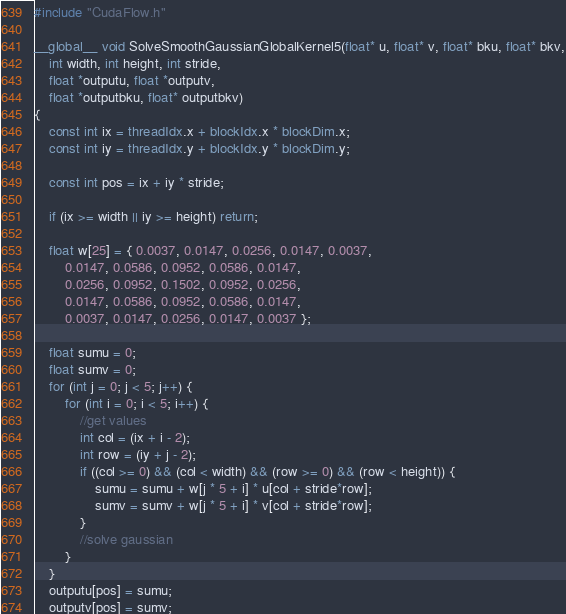<code> <loc_0><loc_0><loc_500><loc_500><_Cuda_>#include "CudaFlow.h"

__global__ void SolveSmoothGaussianGlobalKernel5(float* u, float* v, float* bku, float* bkv,
	int width, int height, int stride,
	float *outputu, float *outputv,
	float *outputbku, float* outputbkv)
{
	const int ix = threadIdx.x + blockIdx.x * blockDim.x;
	const int iy = threadIdx.y + blockIdx.y * blockDim.y;

	const int pos = ix + iy * stride;

	if (ix >= width || iy >= height) return;

	float w[25] = { 0.0037, 0.0147, 0.0256, 0.0147, 0.0037,
		0.0147, 0.0586, 0.0952, 0.0586, 0.0147,
		0.0256, 0.0952, 0.1502, 0.0952, 0.0256,
		0.0147, 0.0586, 0.0952, 0.0586, 0.0147,
		0.0037, 0.0147, 0.0256, 0.0147, 0.0037 };

	float sumu = 0;
	float sumv = 0;
	for (int j = 0; j < 5; j++) {
		for (int i = 0; i < 5; i++) {
			//get values
			int col = (ix + i - 2);
			int row = (iy + j - 2);
			if ((col >= 0) && (col < width) && (row >= 0) && (row < height)) {
				sumu = sumu + w[j * 5 + i] * u[col + stride*row];
				sumv = sumv + w[j * 5 + i] * v[col + stride*row];
			}
			//solve gaussian
		}
	}
	outputu[pos] = sumu;
	outputv[pos] = sumv;</code> 